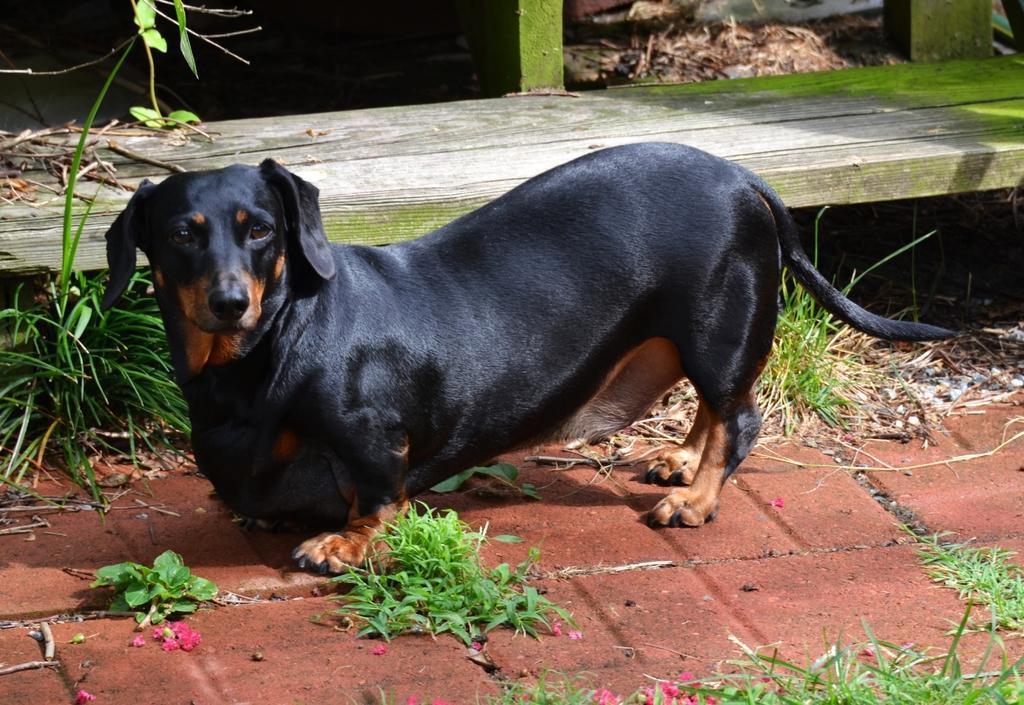In one or two sentences, can you explain what this image depicts? In this image I can see a dog which is in black color, background I can see a bench, and plants in green color. 